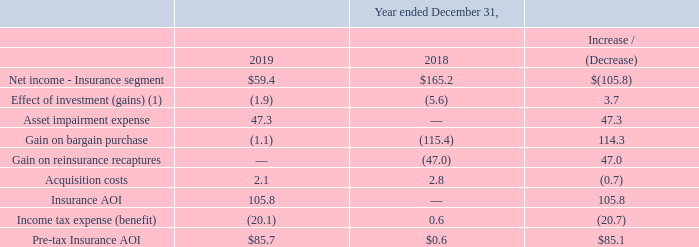Adjusted Operating Income - Insurance
Adjusted Operating Income ("Insurance AOI") and Pre-tax Adjusted Operating Income (“Pre-tax Insurance AOI”) for the Insurance segment are non-U.S. GAAP financial measures frequently used throughout the insurance industry and are economic measures the Insurance segment uses to evaluate its financial performance. Management believes that Insurance AOI and Pretax Insurance AOI measures provide investors with meaningful information for gaining an understanding of certain results and provide insight into an organization’s operating trends and facilitates comparisons between peer companies. However, Insurance AOI and Pre-tax Insurance AOI have certain limitations, and we may not calculate it the same as other companies in our industry. It should, therefore, be read together with the Company's results calculated in accordance with U.S. GAAP.
Similarly to Adjusted EBITDA, using Insurance AOI and Pre-tax Insurance AOI as performance measures have inherent limitations as an analytical tool as compared to income (loss) from operations or other U.S. GAAP financial measures, as these non-U.S. GAAP measures exclude certain items, including items that are recurring in nature, which may be meaningful to investors. As a result of the exclusions, Insurance AOI and Pre-tax Insurance AOI should not be considered in isolation and do not purport to be an alternative to income (loss) from operations or other U.S. GAAP financial measures as measures of our operating performance.
Management defines Pre-tax Insurance AOI as Insurance AOI adjusted to exclude the impact of income tax (benefit) expense recognized during the current period. Management believes that Insurance AOI and Pre-tax Insurance AOI provide meaningful financial metrics that help investors understand certain results and profitability. While these adjustments are an integral part of the overall performance of the Insurance segment, market conditions impacting these items can overshadow the underlying performance of the business. Accordingly, we believe using a measure which excludes their impact is effective in analyzing the trends of our operations.
The table below shows the adjustments made to the reported Net income (loss) of the Insurance segment to calculate Insurance AOI and Pre-tax Insurance AOI (in millions). Refer to the analysis of the fluctuations within the results of operations section:
(1) The Insurance segment revenues are inclusive of realized and unrealized gains and net investment income for the year ended December 31, 2019 and 2018. Such adjustments are related to transactions between entities under common control which are eliminated or are reclassified in consolidation.
Net income for the year ended December 31, 2019 decreased $105.8 million to $59.4 million from $165.2 million for the year ended December 31, 2018. Pre-tax Insurance AOI for the year ended December 31, 2019 increased $85.1 million to $85.7 million from $0.6 million for year ended December 31, 2018. The increase was primarily driven by the incremental net investment income and policy premiums from the KIC block acquisition and higher net investment income from the legacy CGI block driven by both the growth and mix of the investment portfolio, including premium reinvestment and rotation into higher yield assets. In addition, there was a decrease in policy benefits, changes in reserves, and commissions related to current period reserve adjustments driven by higher mortality and policy terminations, an increase in contingent non-forfeiture option activity as a result of in-force rate actions approved and implemented, and favorable developments in claims activity. This was partially offset by an increase in selling, general and administrative expenses, primarily attributable to headcount additions related to the KIC acquisition.
What was the increase / (decrease) in the net income - insurance segment from 2018 to 2019?
Answer scale should be: million. $(105.8). What was the increase / (decrease) in the effect of investment gains from 2018 to 2019?
Answer scale should be: million. 3.7. What was the increase / (decrease) in the asset impairment expense from 2018 to 2019?
Answer scale should be: million. 47.3. What is the percentage increase / (decrease) in the net income - insurance segment from 2018 to 2019?
Answer scale should be: percent. 59.4 / 165.2 - 1
Answer: -64.04. What is the average effect of investment gains?
Answer scale should be: million. -(1.9 + 5.6) / 2
Answer: -3.75. What is the percentage increase / (decrease) in the gain on bargain purchase from 2018 to 2019?
Answer scale should be: percent. -1.1 / -115.4 - 1
Answer: -99.05. 